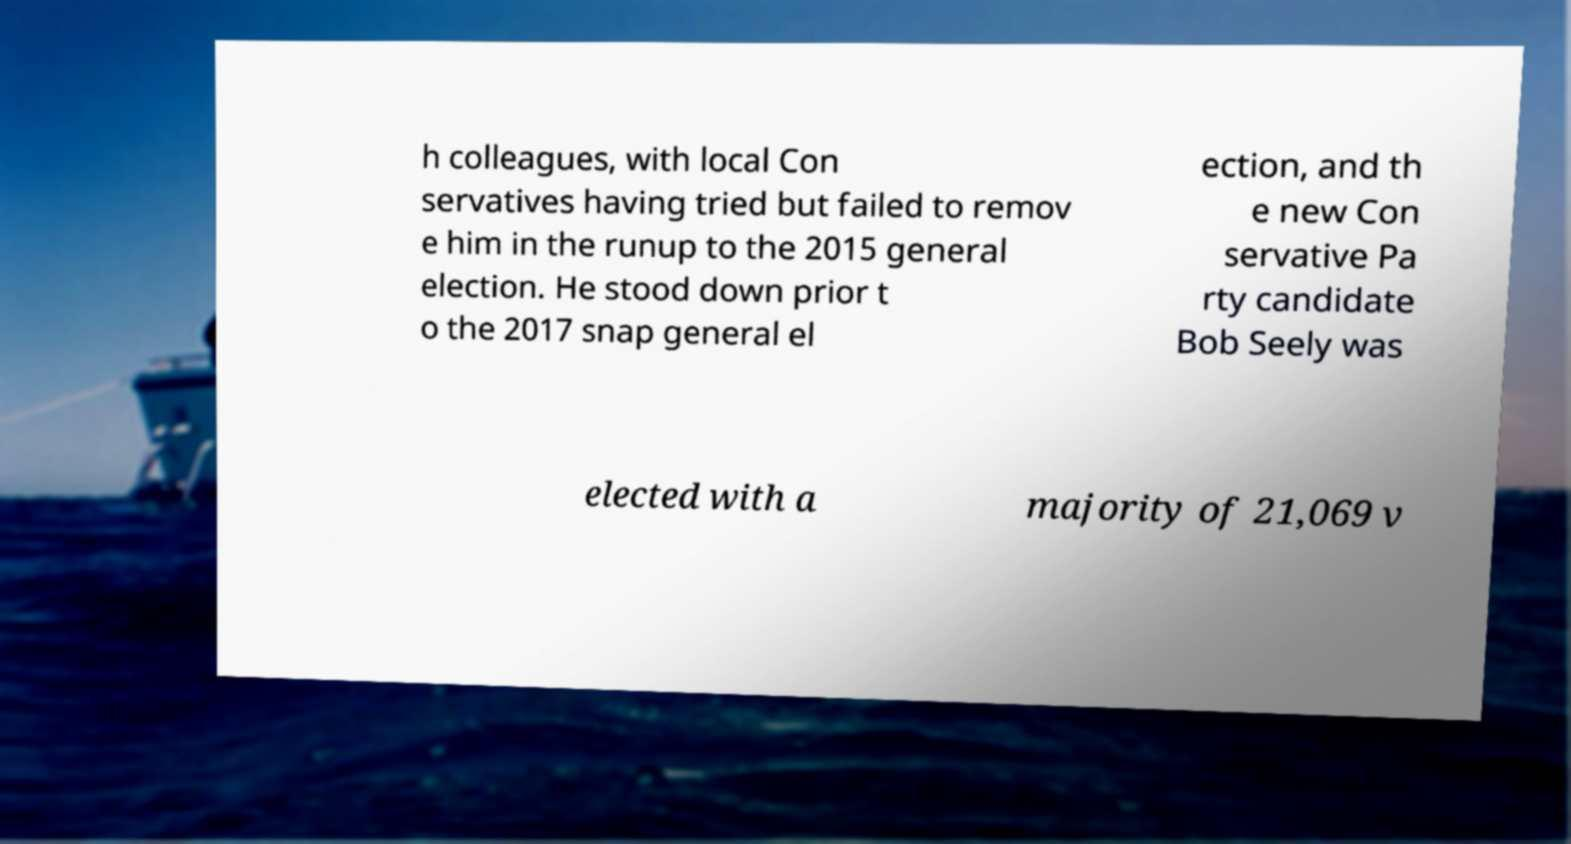Please read and relay the text visible in this image. What does it say? h colleagues, with local Con servatives having tried but failed to remov e him in the runup to the 2015 general election. He stood down prior t o the 2017 snap general el ection, and th e new Con servative Pa rty candidate Bob Seely was elected with a majority of 21,069 v 